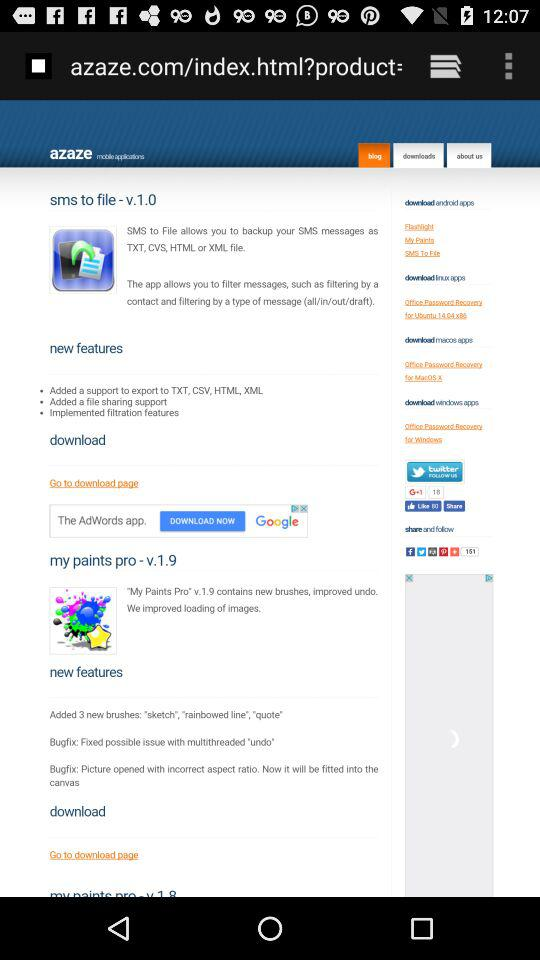What are the new features of "my paints pro"? The new features are "Added 3 new brushes: "sketch", "rainbowed line", "quote"", "Bugfix: Fixed possible issue with multithreaded "undo"" and "Bugfix: Picture opened with incorrect aspect ratio. Now it will be fitted into the canvas". 